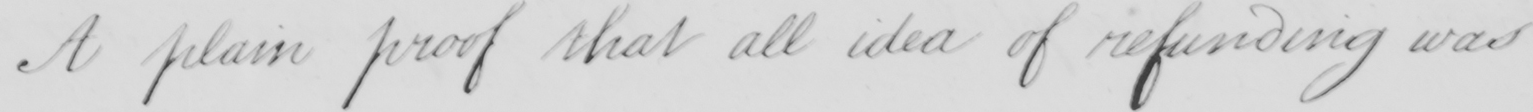What does this handwritten line say? A plain proof that all idea of refunding was 